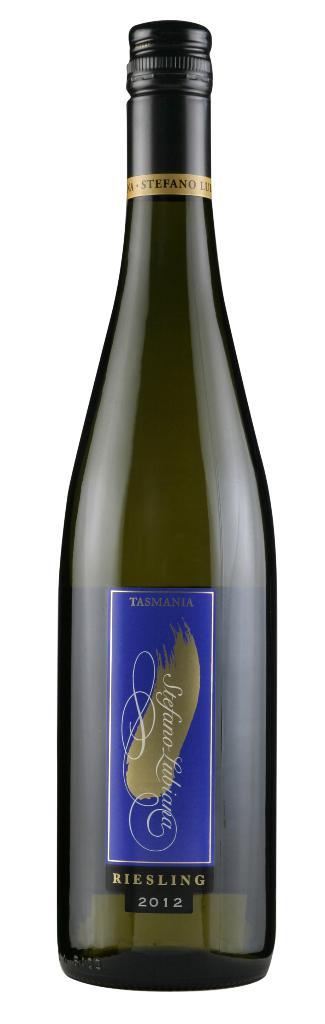What brand is the wine?
Make the answer very short. Tasmania. 